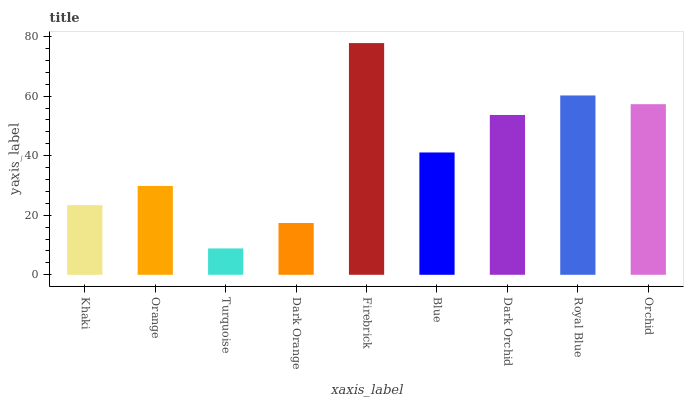Is Turquoise the minimum?
Answer yes or no. Yes. Is Firebrick the maximum?
Answer yes or no. Yes. Is Orange the minimum?
Answer yes or no. No. Is Orange the maximum?
Answer yes or no. No. Is Orange greater than Khaki?
Answer yes or no. Yes. Is Khaki less than Orange?
Answer yes or no. Yes. Is Khaki greater than Orange?
Answer yes or no. No. Is Orange less than Khaki?
Answer yes or no. No. Is Blue the high median?
Answer yes or no. Yes. Is Blue the low median?
Answer yes or no. Yes. Is Dark Orange the high median?
Answer yes or no. No. Is Khaki the low median?
Answer yes or no. No. 